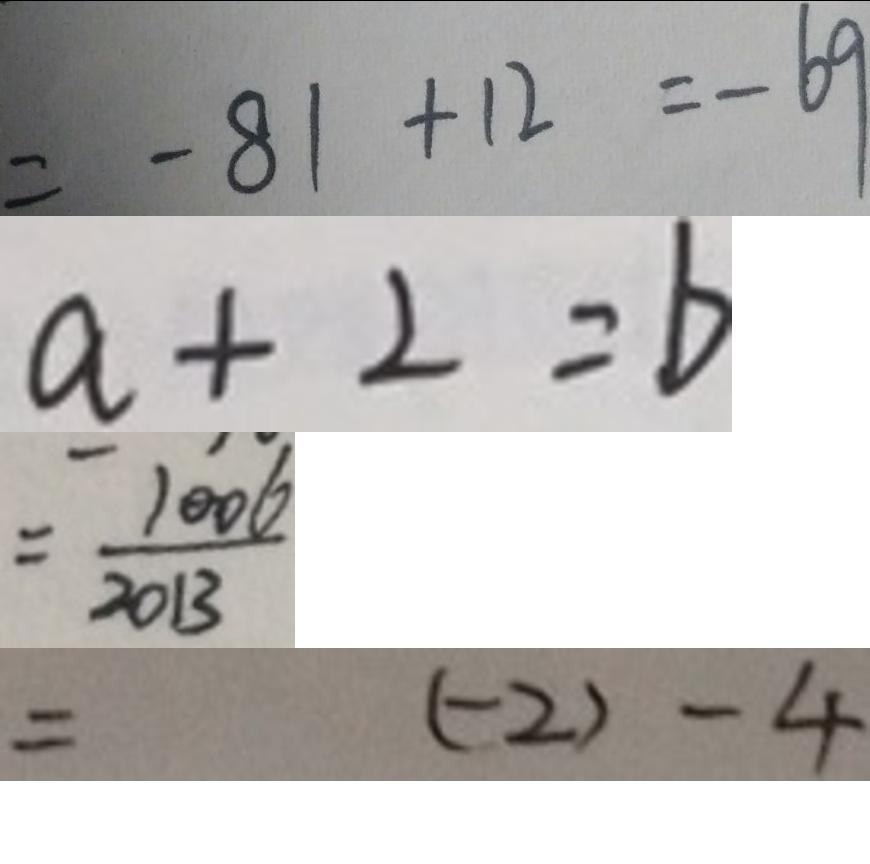Convert formula to latex. <formula><loc_0><loc_0><loc_500><loc_500>= - 8 1 + 1 2 = - 6 9 
 a + 2 = b 
 = \frac { 1 0 0 6 } { 2 0 1 3 } 
 = ( - 2 ) - 4</formula> 